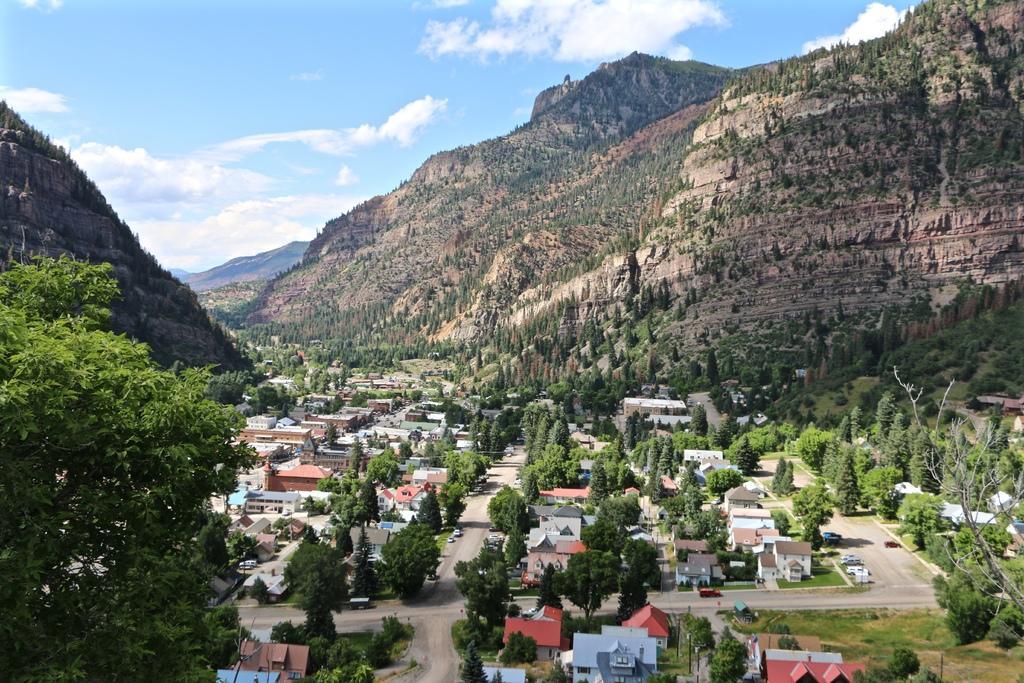Could you give a brief overview of what you see in this image? In this image we can see a few houses, there are some trees and vehicles, in the background, we can see the sky with clouds. 